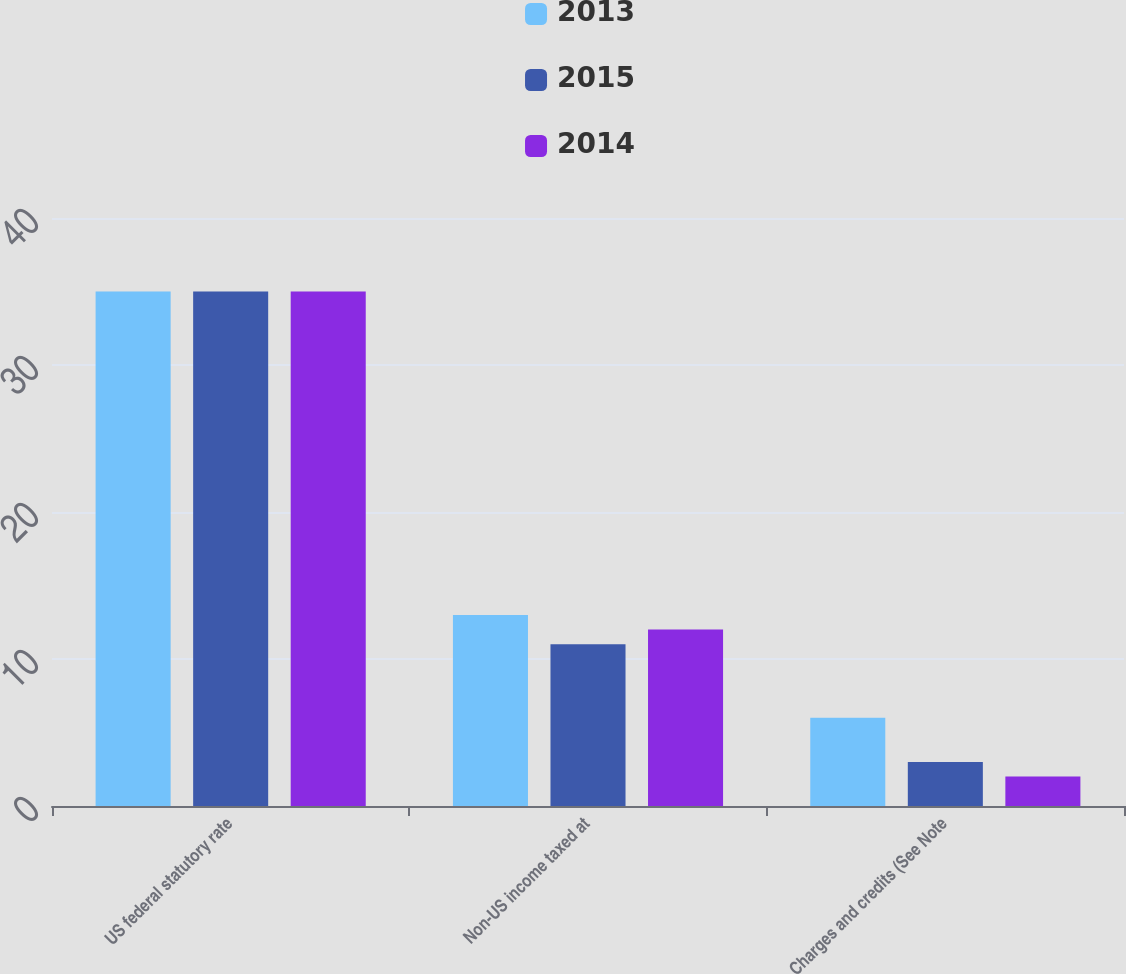Convert chart. <chart><loc_0><loc_0><loc_500><loc_500><stacked_bar_chart><ecel><fcel>US federal statutory rate<fcel>Non-US income taxed at<fcel>Charges and credits (See Note<nl><fcel>2013<fcel>35<fcel>13<fcel>6<nl><fcel>2015<fcel>35<fcel>11<fcel>3<nl><fcel>2014<fcel>35<fcel>12<fcel>2<nl></chart> 